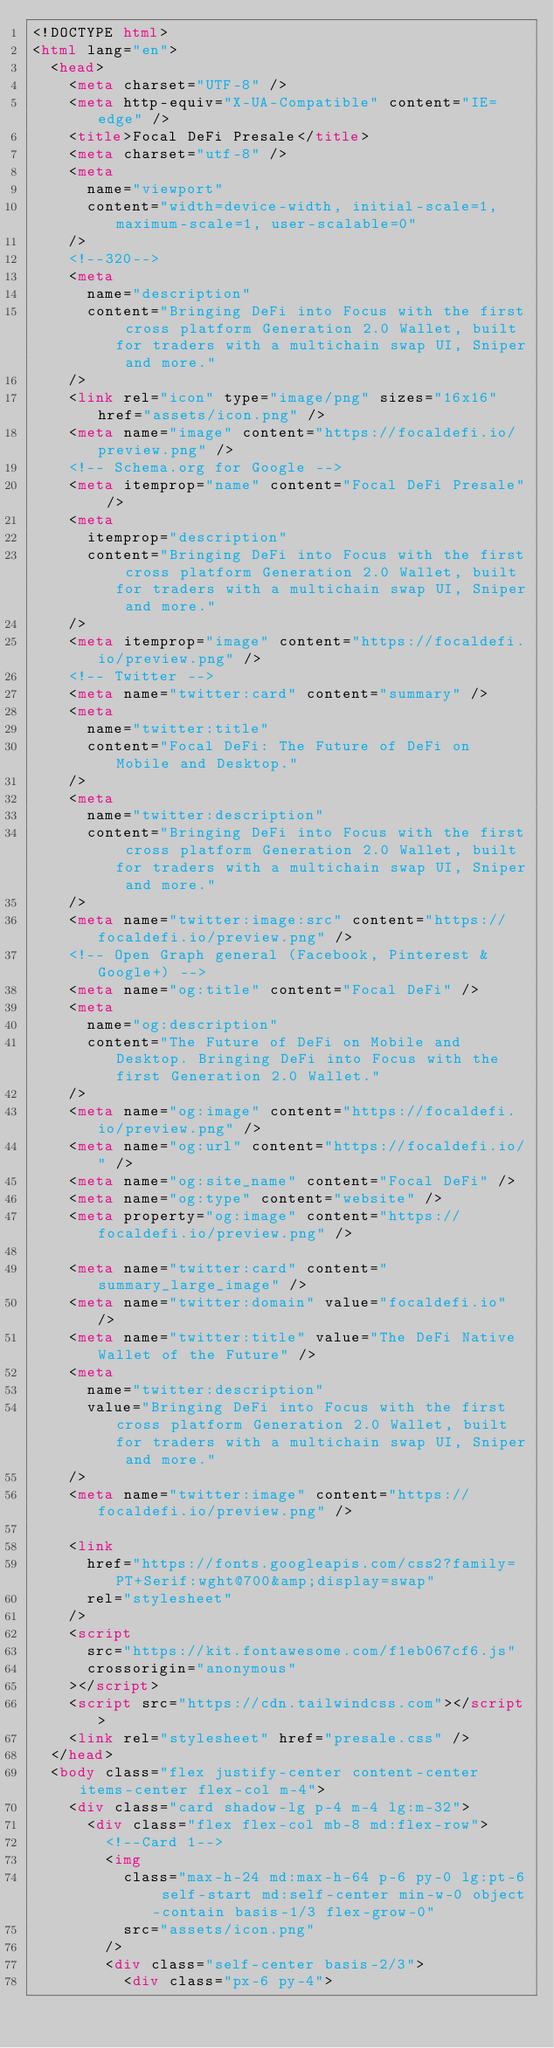<code> <loc_0><loc_0><loc_500><loc_500><_HTML_><!DOCTYPE html>
<html lang="en">
  <head>
    <meta charset="UTF-8" />
    <meta http-equiv="X-UA-Compatible" content="IE=edge" />
    <title>Focal DeFi Presale</title>
    <meta charset="utf-8" />
    <meta
      name="viewport"
      content="width=device-width, initial-scale=1, maximum-scale=1, user-scalable=0"
    />
    <!--320-->
    <meta
      name="description"
      content="Bringing DeFi into Focus with the first cross platform Generation 2.0 Wallet, built for traders with a multichain swap UI, Sniper and more."
    />
    <link rel="icon" type="image/png" sizes="16x16" href="assets/icon.png" />
    <meta name="image" content="https://focaldefi.io/preview.png" />
    <!-- Schema.org for Google -->
    <meta itemprop="name" content="Focal DeFi Presale" />
    <meta
      itemprop="description"
      content="Bringing DeFi into Focus with the first cross platform Generation 2.0 Wallet, built for traders with a multichain swap UI, Sniper and more."
    />
    <meta itemprop="image" content="https://focaldefi.io/preview.png" />
    <!-- Twitter -->
    <meta name="twitter:card" content="summary" />
    <meta
      name="twitter:title"
      content="Focal DeFi: The Future of DeFi on Mobile and Desktop."
    />
    <meta
      name="twitter:description"
      content="Bringing DeFi into Focus with the first cross platform Generation 2.0 Wallet, built for traders with a multichain swap UI, Sniper and more."
    />
    <meta name="twitter:image:src" content="https://focaldefi.io/preview.png" />
    <!-- Open Graph general (Facebook, Pinterest & Google+) -->
    <meta name="og:title" content="Focal DeFi" />
    <meta
      name="og:description"
      content="The Future of DeFi on Mobile and Desktop. Bringing DeFi into Focus with the first Generation 2.0 Wallet."
    />
    <meta name="og:image" content="https://focaldefi.io/preview.png" />
    <meta name="og:url" content="https://focaldefi.io/" />
    <meta name="og:site_name" content="Focal DeFi" />
    <meta name="og:type" content="website" />
    <meta property="og:image" content="https://focaldefi.io/preview.png" />

    <meta name="twitter:card" content="summary_large_image" />
    <meta name="twitter:domain" value="focaldefi.io" />
    <meta name="twitter:title" value="The DeFi Native Wallet of the Future" />
    <meta
      name="twitter:description"
      value="Bringing DeFi into Focus with the first cross platform Generation 2.0 Wallet, built for traders with a multichain swap UI, Sniper and more."
    />
    <meta name="twitter:image" content="https://focaldefi.io/preview.png" />

    <link
      href="https://fonts.googleapis.com/css2?family=PT+Serif:wght@700&amp;display=swap"
      rel="stylesheet"
    />
    <script
      src="https://kit.fontawesome.com/f1eb067cf6.js"
      crossorigin="anonymous"
    ></script>
    <script src="https://cdn.tailwindcss.com"></script>
    <link rel="stylesheet" href="presale.css" />
  </head>
  <body class="flex justify-center content-center items-center flex-col m-4">
    <div class="card shadow-lg p-4 m-4 lg:m-32">
      <div class="flex flex-col mb-8 md:flex-row">
        <!--Card 1-->
        <img
          class="max-h-24 md:max-h-64 p-6 py-0 lg:pt-6 self-start md:self-center min-w-0 object-contain basis-1/3 flex-grow-0"
          src="assets/icon.png"
        />
        <div class="self-center basis-2/3">
          <div class="px-6 py-4"></code> 